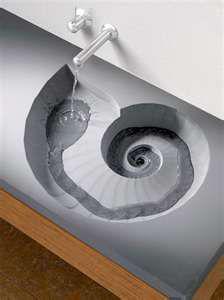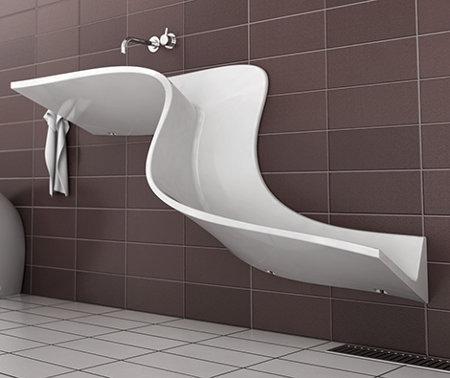The first image is the image on the left, the second image is the image on the right. Considering the images on both sides, is "The sink in the image on the left curves down toward the floor." valid? Answer yes or no. No. 